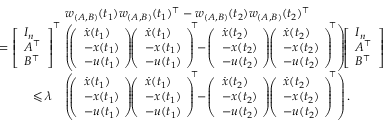Convert formula to latex. <formula><loc_0><loc_0><loc_500><loc_500>\begin{array} { r l } & { w _ { ( A , B ) } ( t _ { 1 } ) w _ { ( A , B ) } ( t _ { 1 } ) ^ { \top } - w _ { ( A , B ) } ( t _ { 2 } ) w _ { ( A , B ) } ( t _ { 2 } ) ^ { \top } } \\ { = \left [ \begin{array} { l } { I _ { n } } \\ { A ^ { \top } } \\ { B ^ { \top } } \end{array} \right ] ^ { \top } \, } & { \left ( \, \left ( \begin{array} { l } { \dot { x } ( t _ { 1 } ) } \\ { - x ( t _ { 1 } ) \, } \\ { - u ( t _ { 1 } ) \, } \end{array} \right ) \, \left ( \begin{array} { l } { \dot { x } ( t _ { 1 } ) } \\ { - x ( t _ { 1 } ) \, } \\ { - u ( t _ { 1 } ) \, } \end{array} \right ) ^ { \, \top } \, - \, \left ( \begin{array} { l } { \dot { x } ( t _ { 2 } ) } \\ { - x ( t _ { 2 } ) \, } \\ { - u ( t _ { 2 } ) \, } \end{array} \right ) \, \left ( \begin{array} { l } { \dot { x } ( t _ { 2 } ) } \\ { - x ( t _ { 2 } ) \, } \\ { - u ( t _ { 2 } ) \, } \end{array} \right ) ^ { \, \top } \right ) \, \left [ \begin{array} { l } { I _ { n } } \\ { A ^ { \top } } \\ { B ^ { \top } } \end{array} \right ] } \\ { \leqslant \lambda } & { \left ( \, \left ( \begin{array} { l } { \dot { x } ( t _ { 1 } ) } \\ { - x ( t _ { 1 } ) \, } \\ { - u ( t _ { 1 } ) \, } \end{array} \right ) \, \left ( \begin{array} { l } { \dot { x } ( t _ { 1 } ) } \\ { - x ( t _ { 1 } ) \, } \\ { - u ( t _ { 1 } ) \, } \end{array} \right ) ^ { \, \top } \, - \, \left ( \begin{array} { l } { \dot { x } ( t _ { 2 } ) } \\ { - x ( t _ { 2 } ) \, } \\ { - u ( t _ { 2 } ) \, } \end{array} \right ) \, \left ( \begin{array} { l } { \dot { x } ( t _ { 2 } ) } \\ { - x ( t _ { 2 } ) \, } \\ { - u ( t _ { 2 } ) \, } \end{array} \right ) ^ { \, \top } \right ) . } \end{array}</formula> 